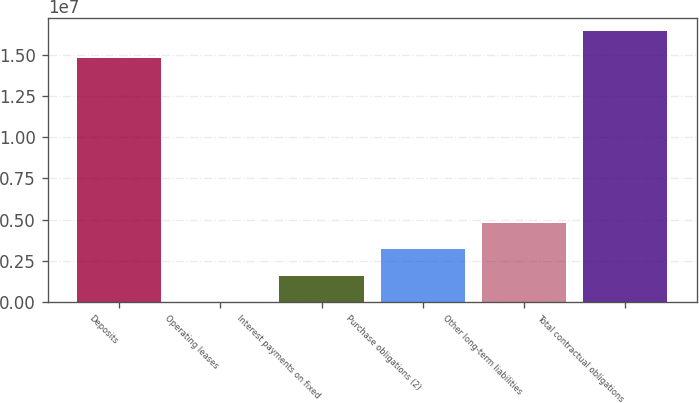<chart> <loc_0><loc_0><loc_500><loc_500><bar_chart><fcel>Deposits<fcel>Operating leases<fcel>Interest payments on fixed<fcel>Purchase obligations (2)<fcel>Other long-term liabilities<fcel>Total contractual obligations<nl><fcel>1.48268e+07<fcel>6068<fcel>1.59897e+06<fcel>3.19187e+06<fcel>4.78477e+06<fcel>1.64197e+07<nl></chart> 